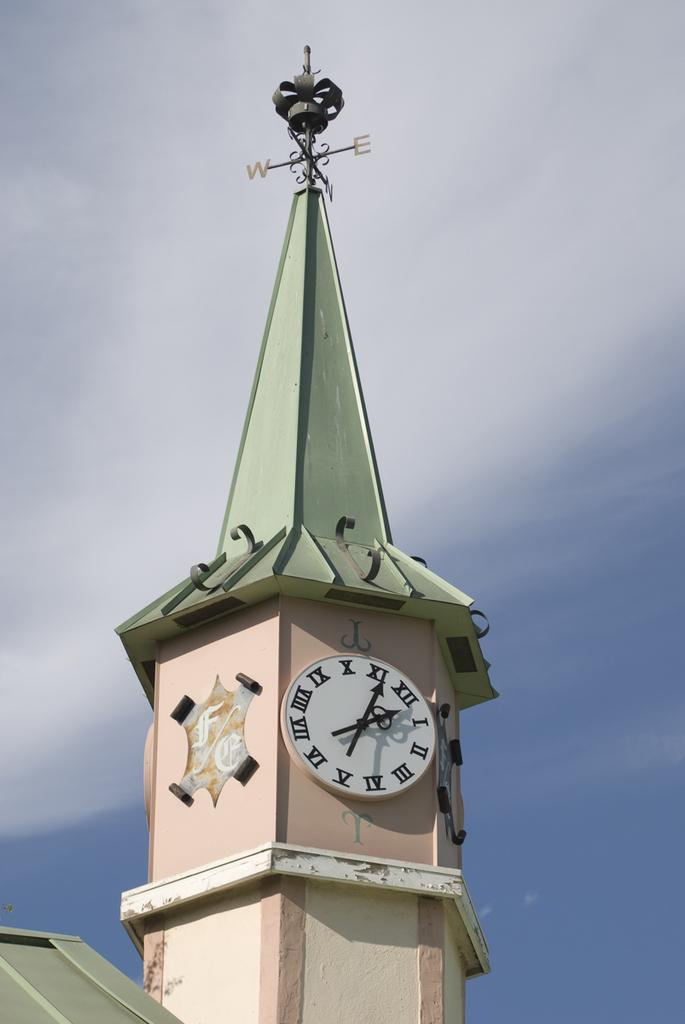<image>
Present a compact description of the photo's key features. Tall building with a green roof which has a compass with the directions W and E. 